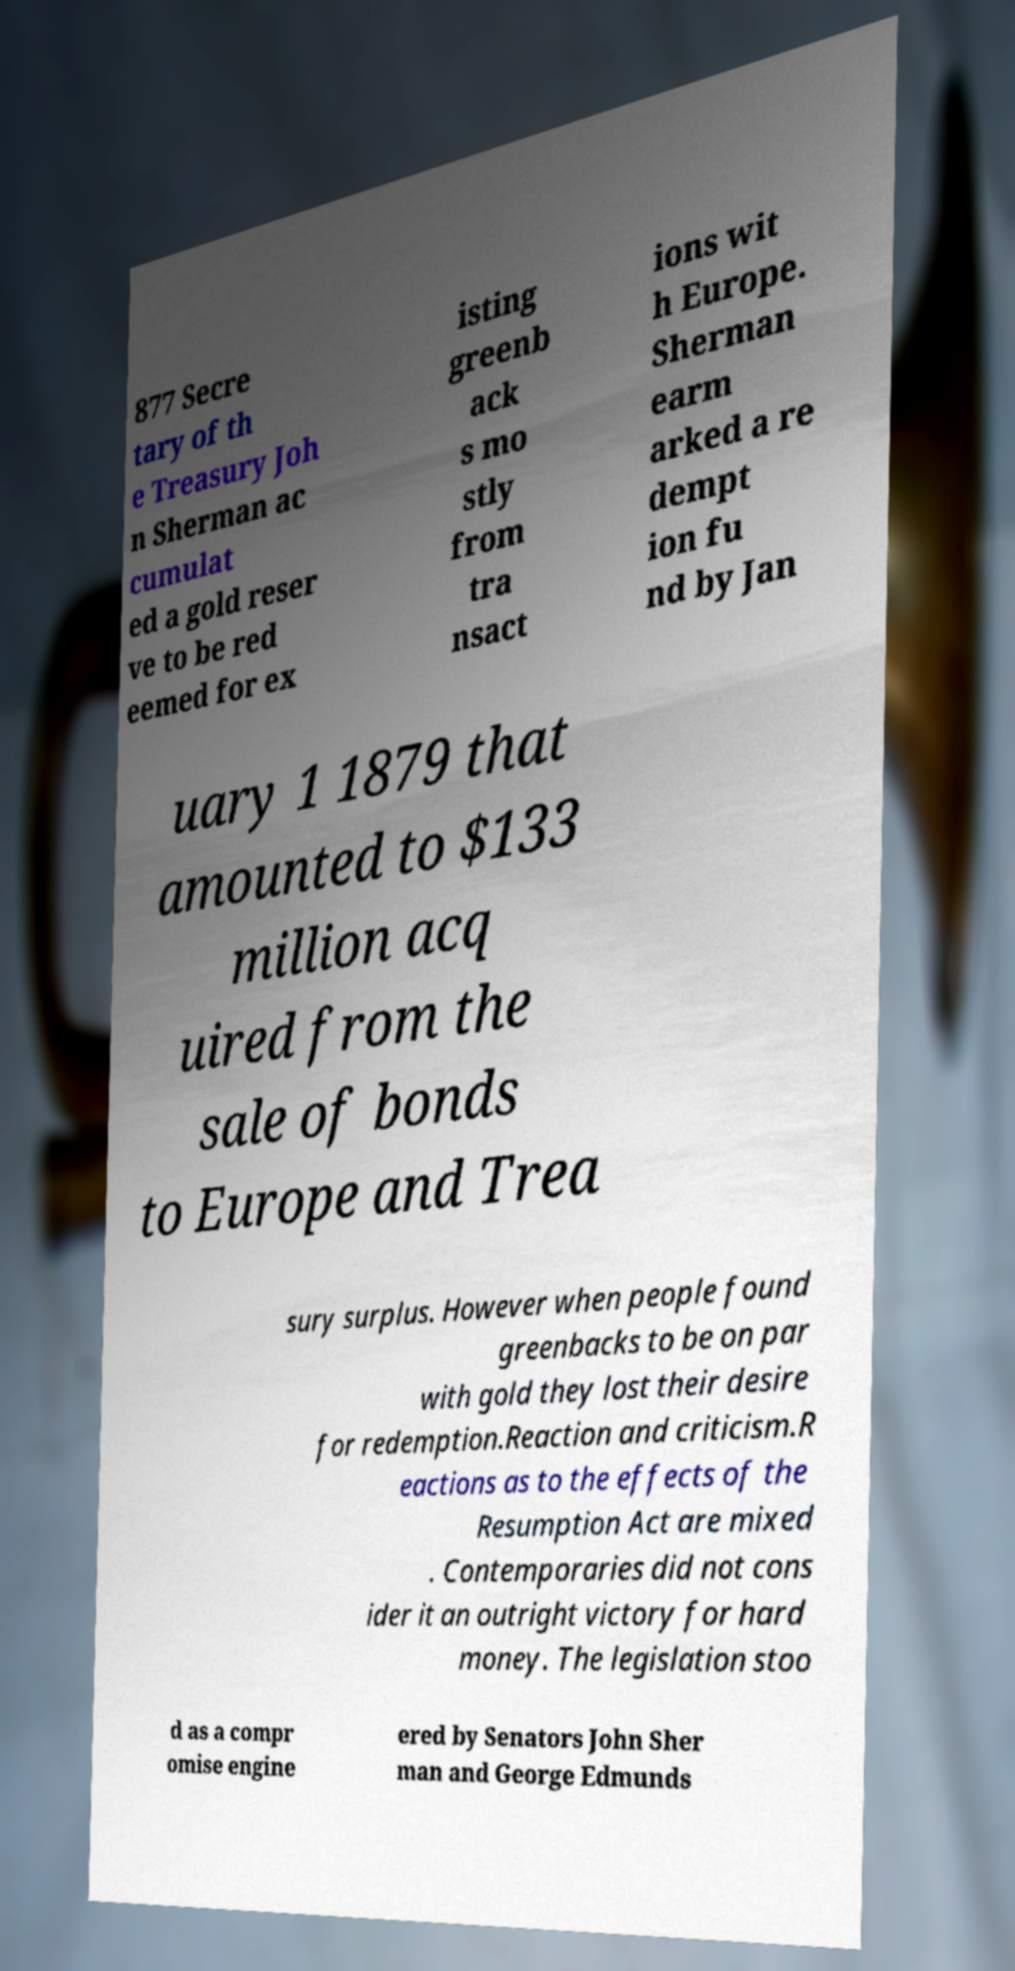What messages or text are displayed in this image? I need them in a readable, typed format. 877 Secre tary of th e Treasury Joh n Sherman ac cumulat ed a gold reser ve to be red eemed for ex isting greenb ack s mo stly from tra nsact ions wit h Europe. Sherman earm arked a re dempt ion fu nd by Jan uary 1 1879 that amounted to $133 million acq uired from the sale of bonds to Europe and Trea sury surplus. However when people found greenbacks to be on par with gold they lost their desire for redemption.Reaction and criticism.R eactions as to the effects of the Resumption Act are mixed . Contemporaries did not cons ider it an outright victory for hard money. The legislation stoo d as a compr omise engine ered by Senators John Sher man and George Edmunds 